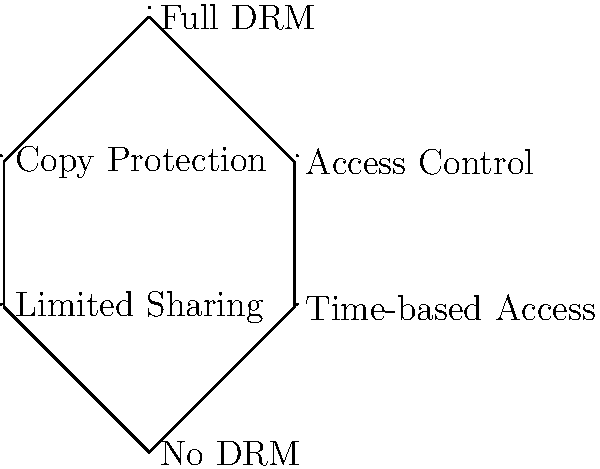In the lattice diagram representing different levels of digital rights management (DRM) for e-books, each node represents a subgroup of the main group "Full DRM". If the order of the "Full DRM" group is 24, what is the order of the subgroup "Limited Sharing"? To solve this problem, we need to use the following steps:

1. Understand the lattice structure:
   - "Full DRM" is at the top, representing the entire group.
   - Each level down represents subgroups with fewer restrictions.
   - "Limited Sharing" is two levels down from "Full DRM".

2. Apply Lagrange's Theorem:
   - The order of any subgroup must divide the order of the full group.
   - The order of the full group is 24.

3. Analyze the levels:
   - There are three levels in the lattice.
   - Each level represents a division of the group above it.

4. Calculate possible orders:
   - The divisors of 24 are: 1, 2, 3, 4, 6, 8, 12, 24.
   - "Limited Sharing" is two levels down, so we need to divide twice.
   - 24 ÷ 2 = 12 (first level)
   - 12 ÷ 2 = 6 (second level, where "Limited Sharing" is)

Therefore, the order of the "Limited Sharing" subgroup is 6.
Answer: 6 